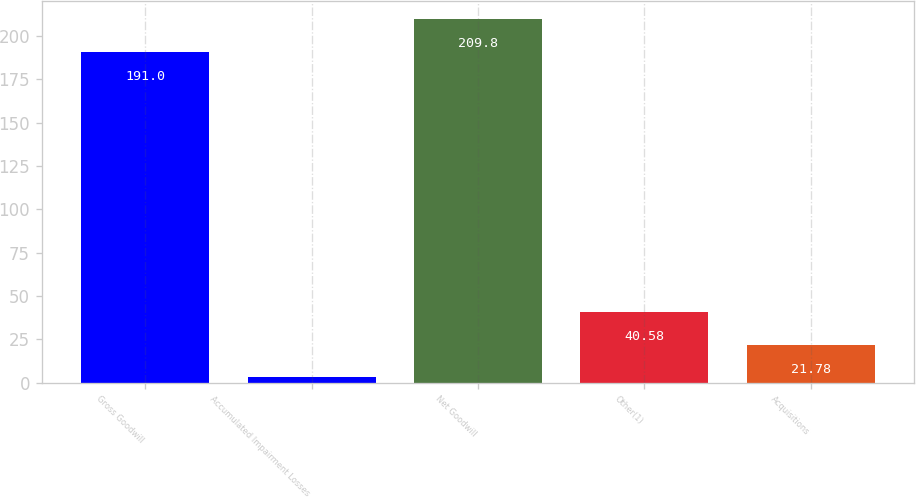<chart> <loc_0><loc_0><loc_500><loc_500><bar_chart><fcel>Gross Goodwill<fcel>Accumulated Impairment Losses<fcel>Net Goodwill<fcel>Other(1)<fcel>Acquisitions<nl><fcel>191<fcel>2.98<fcel>209.8<fcel>40.58<fcel>21.78<nl></chart> 